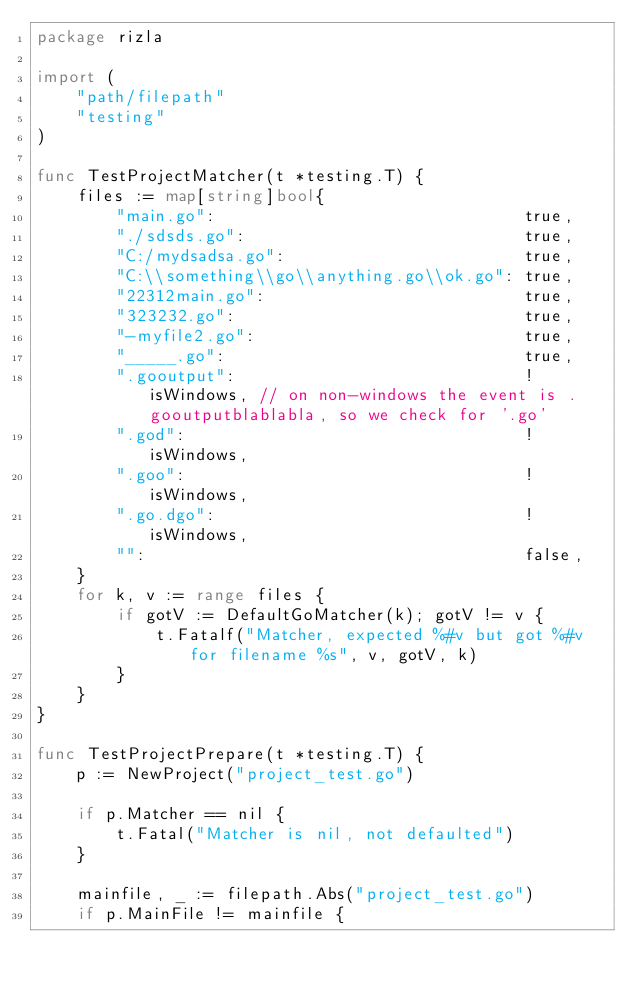Convert code to text. <code><loc_0><loc_0><loc_500><loc_500><_Go_>package rizla

import (
	"path/filepath"
	"testing"
)

func TestProjectMatcher(t *testing.T) {
	files := map[string]bool{
		"main.go":                               true,
		"./sdsds.go":                            true,
		"C:/mydsadsa.go":                        true,
		"C:\\something\\go\\anything.go\\ok.go": true,
		"22312main.go":                          true,
		"323232.go":                             true,
		"-myfile2.go":                           true,
		"_____.go":                              true,
		".gooutput":                             !isWindows, // on non-windows the event is .gooutputblablabla, so we check for '.go'
		".god":                                  !isWindows,
		".goo":                                  !isWindows,
		".go.dgo":                               !isWindows,
		"":                                      false,
	}
	for k, v := range files {
		if gotV := DefaultGoMatcher(k); gotV != v {
			t.Fatalf("Matcher, expected %#v but got %#v for filename %s", v, gotV, k)
		}
	}
}

func TestProjectPrepare(t *testing.T) {
	p := NewProject("project_test.go")

	if p.Matcher == nil {
		t.Fatal("Matcher is nil, not defaulted")
	}

	mainfile, _ := filepath.Abs("project_test.go")
	if p.MainFile != mainfile {</code> 